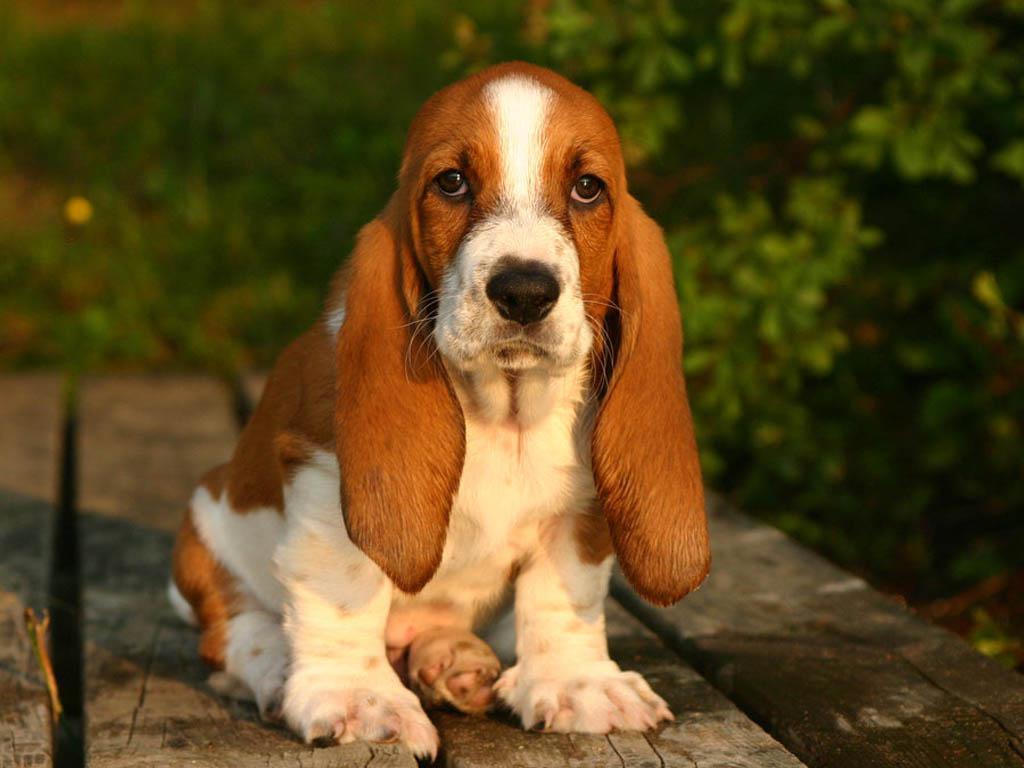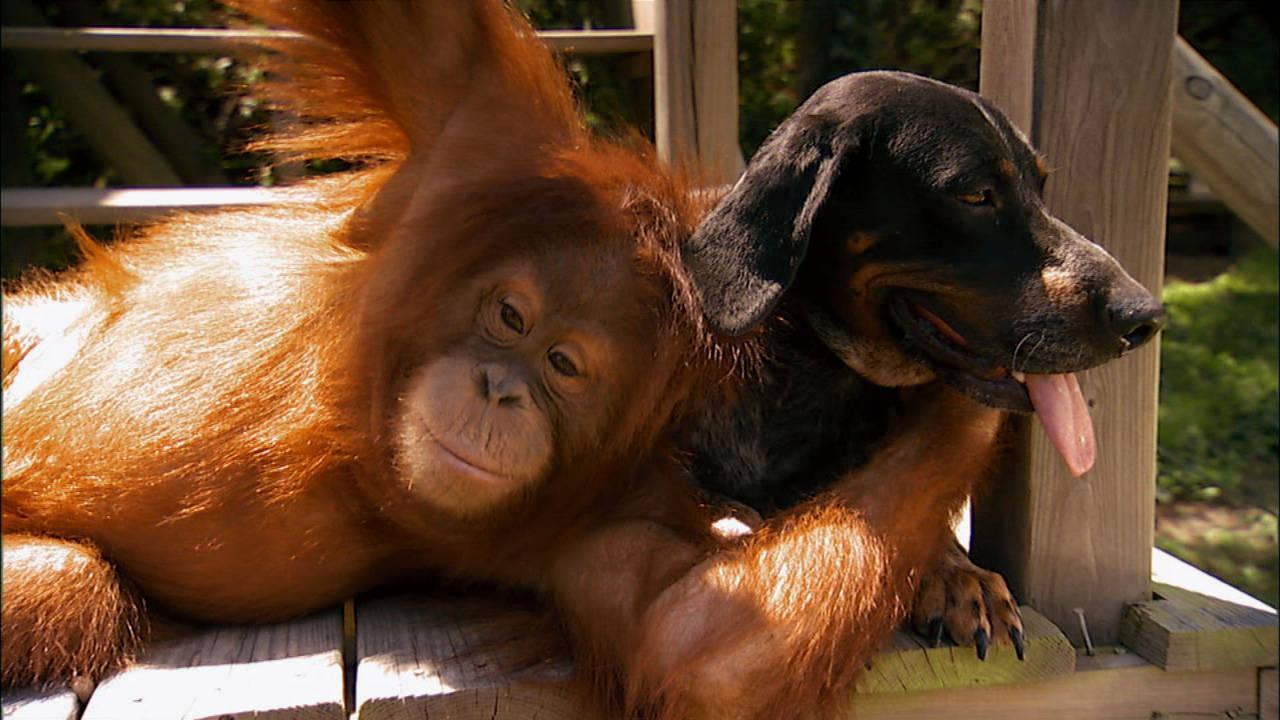The first image is the image on the left, the second image is the image on the right. Given the left and right images, does the statement "the dog's tail is visible in one of the images" hold true? Answer yes or no. No. The first image is the image on the left, the second image is the image on the right. Given the left and right images, does the statement "One image features a basset pup on a wood plank deck outdoors." hold true? Answer yes or no. Yes. 